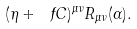Convert formula to latex. <formula><loc_0><loc_0><loc_500><loc_500>( \eta + \ f C ) ^ { \mu \nu } R _ { \mu \nu } ( \Gamma ) .</formula> 